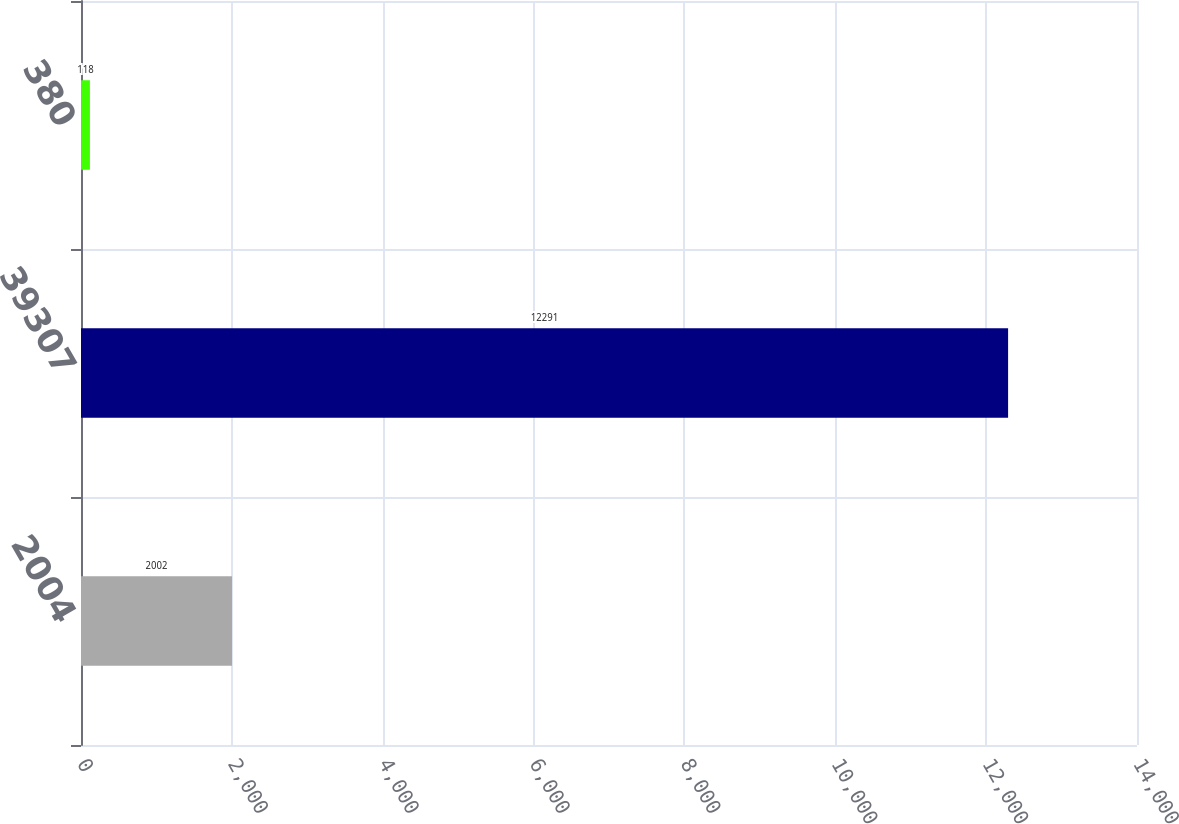Convert chart. <chart><loc_0><loc_0><loc_500><loc_500><bar_chart><fcel>2004<fcel>39307<fcel>380<nl><fcel>2002<fcel>12291<fcel>118<nl></chart> 